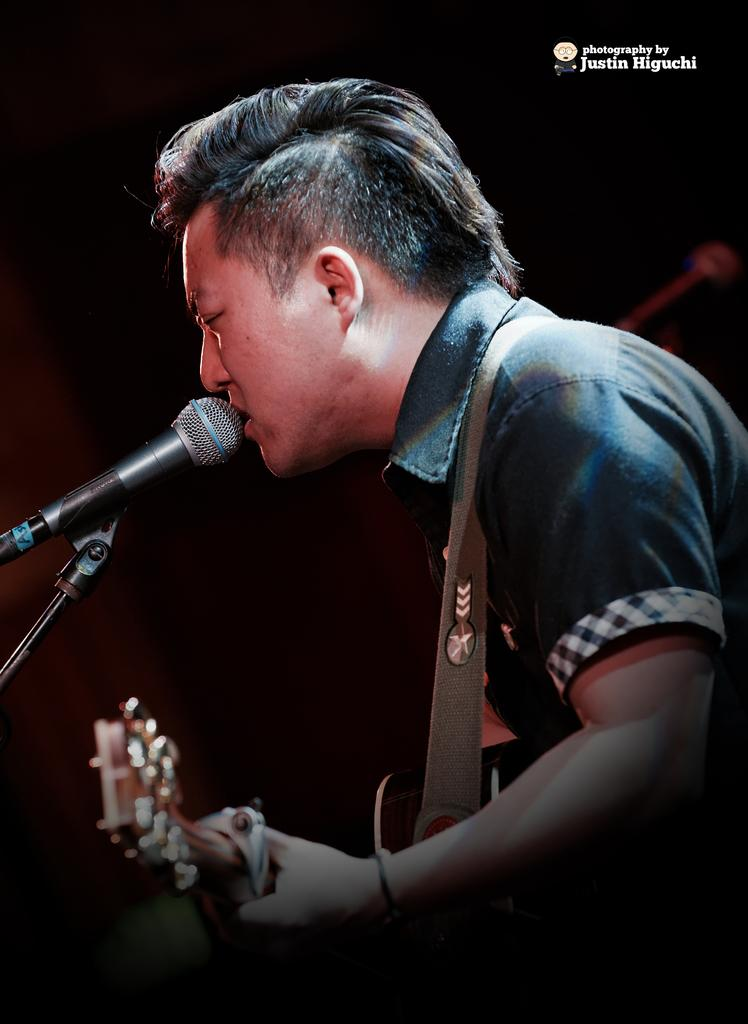Who is the main subject in the image? There is a man in the image. What is the man holding in the image? The man is holding a guitar. What activity is the man engaged in? The man is singing on a microphone. What type of scissors is the man using to cut the microphone cord in the image? There are no scissors present in the image, nor is the man cutting any cords. 